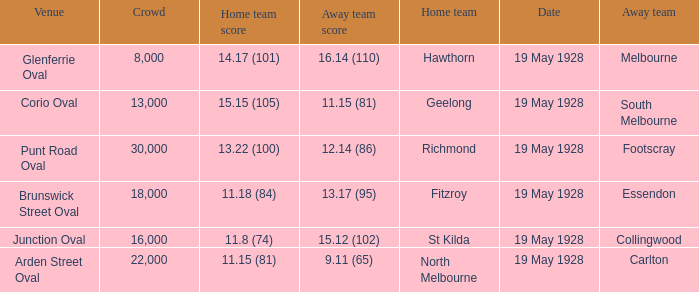What is the listed crowd when essendon is the away squad? 1.0. 